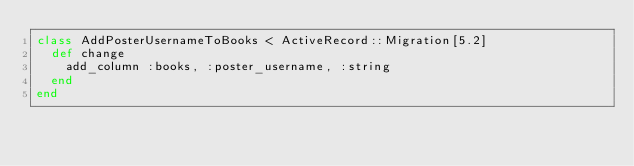<code> <loc_0><loc_0><loc_500><loc_500><_Ruby_>class AddPosterUsernameToBooks < ActiveRecord::Migration[5.2]
  def change
    add_column :books, :poster_username, :string
  end
end
</code> 